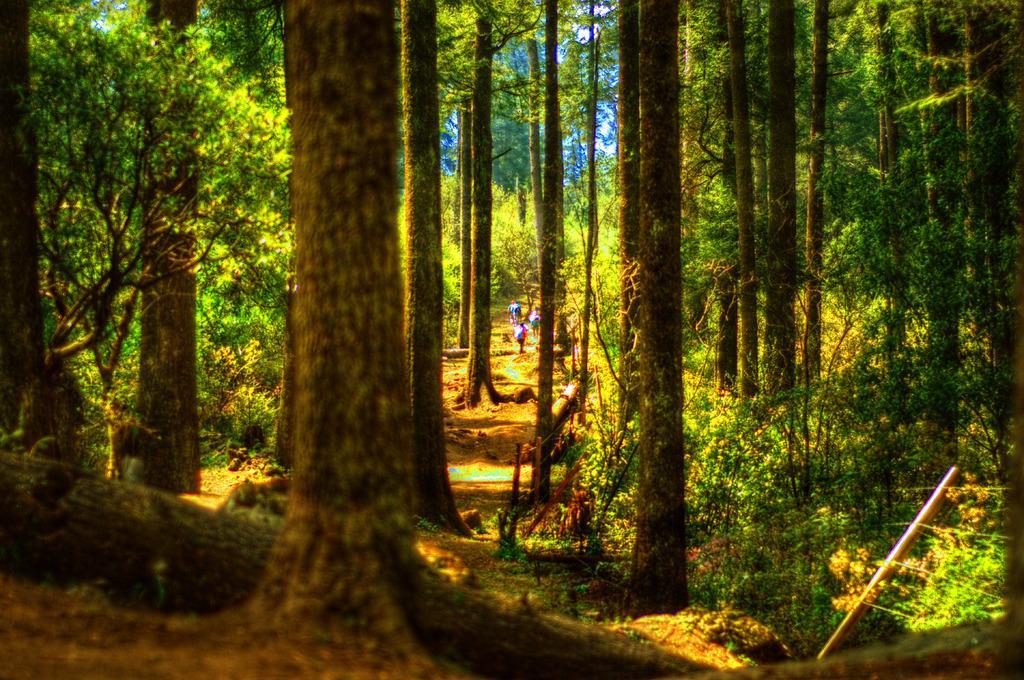Could you give a brief overview of what you see in this image? In this image I can see number of trees, a pole, few wires and over there I can see few people are standing. 